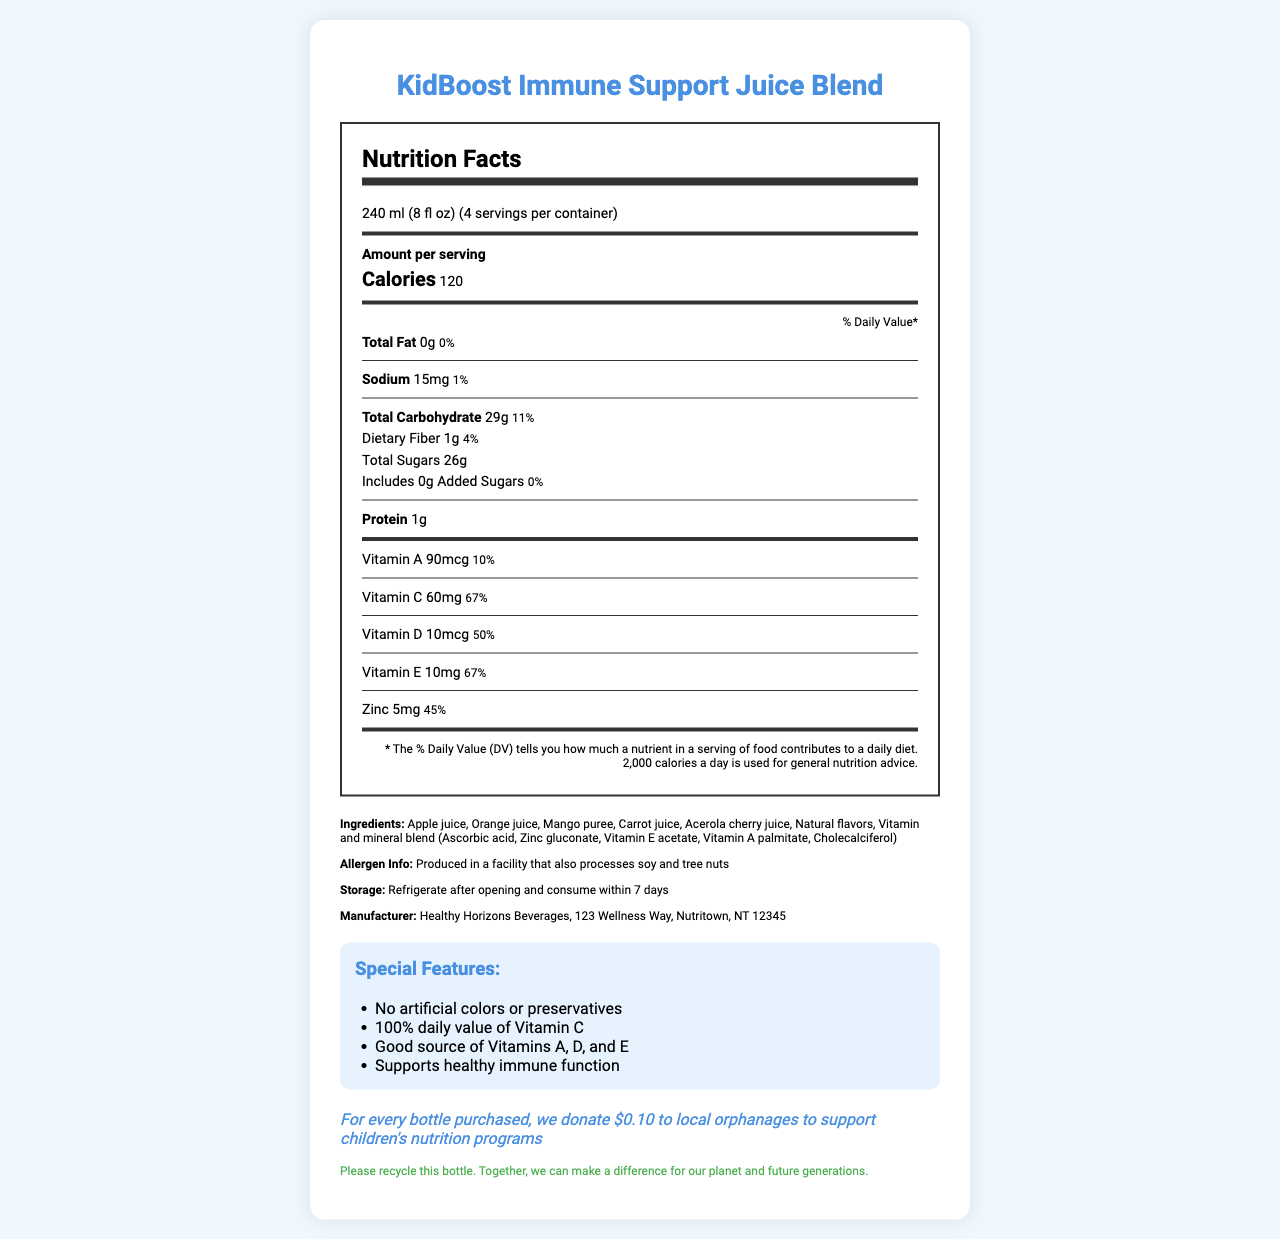what is the name of the product? The product name is clearly indicated at the top of the document.
Answer: KidBoost Immune Support Juice Blend what is the serving size of the juice blend? The serving size is specified near the top of the Nutrition Facts section.
Answer: 240 ml (8 fl oz) how many calories are in one serving? The number of calories per serving is shown prominently under the 'Amount per serving' section.
Answer: 120 what vitamins are included in this juice blend? The vitamins are listed under the nutrients section within the Nutrition Facts.
Answer: Vitamins A, C, D, and E how much dietary fiber is in one serving? The amount of dietary fiber is specified under the Total Carbohydrate section of the Nutrition Facts label.
Answer: 1g what is the percentage of daily value for Sodium? A. 1% B. 5% C. 15% The document shows that the daily value percentage for Sodium is 1%.
Answer: A how many servings are in the entire container? A. 2 B. 3 C. 4 D. 5 The servings per container are listed as 4.
Answer: C does this product contain artificial colors or preservatives? The "Special Features" section states "No artificial colors or preservatives".
Answer: No is this product manufactured in a facility that processes soy and tree nuts? The allergen information mentions that it is produced in a facility that processes soy and tree nuts.
Answer: Yes how does this product support children's health programs? The charity statement at the bottom mentions this.
Answer: For every bottle purchased, $0.10 is donated to local orphanages to support children's nutrition programs summarize the key features of KidBoost Immune Support Juice Blend. The document primarily describes the nutritional content, ingredients, special features, allergen information, and charitable efforts related to the product.
Answer: The KidBoost Immune Support Juice Blend is a vitamin-fortified fruit juice designed to support children's immune systems, containing vitamins A, C, D, and E. It has 120 calories per serving and contains no artificial colors or preservatives. Produced in a facility processing soy and tree nuts, this product supports children's health through donations to local orphanages. can this product be left unrefrigerated after opening? The storage instructions specify to refrigerate after opening.
Answer: No what company manufactures this juice blend? The manufacturer information states it is produced by Healthy Horizons Beverages.
Answer: Healthy Horizons Beverages how much zinc is in one serving? The amount of zinc per serving is stated in the Nutrition Facts section.
Answer: 5mg is it clear how much juice is donated to orphanages? The document specifies that $0.10 per bottle is donated but does not detail how much juice is actually provided.
Answer: Not enough information 